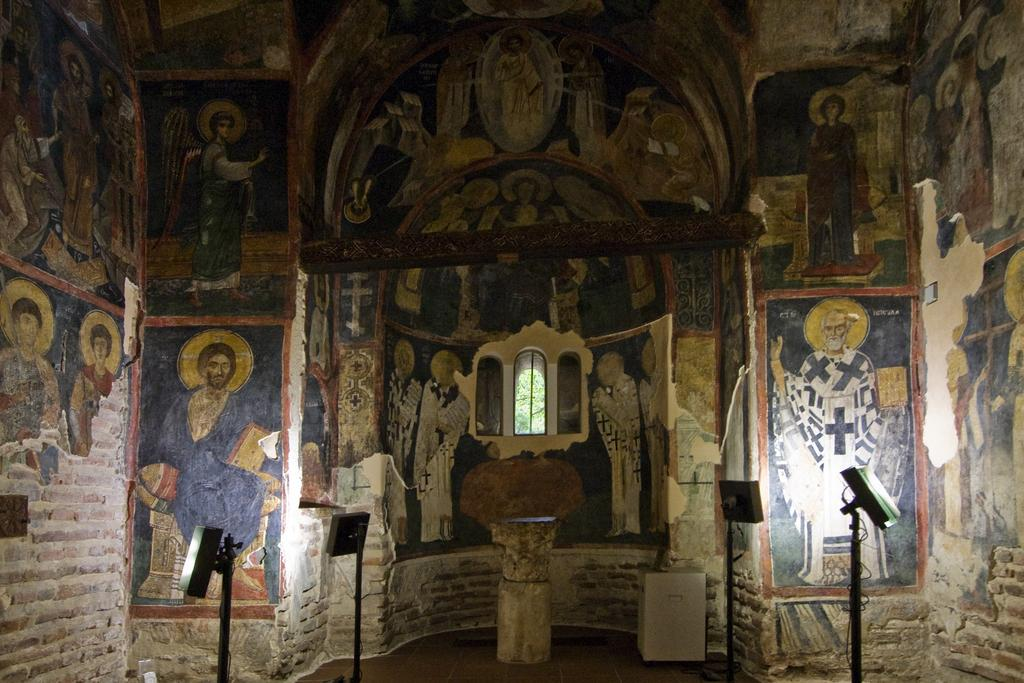What can be seen in the image that provides illumination? There are lights in the image. What is visible in the background of the image? There is a window visible in the background of the image. What type of artwork is present on the wall in the image? There is a painting of people on the wall. Can you tell me how many tigers are represented in the painting on the wall? There are no tigers present in the painting on the wall; it features people. What type of representative is depicted in the painting on the wall? The painting on the wall is not a representation of a specific person or group; it is a painting of people. 